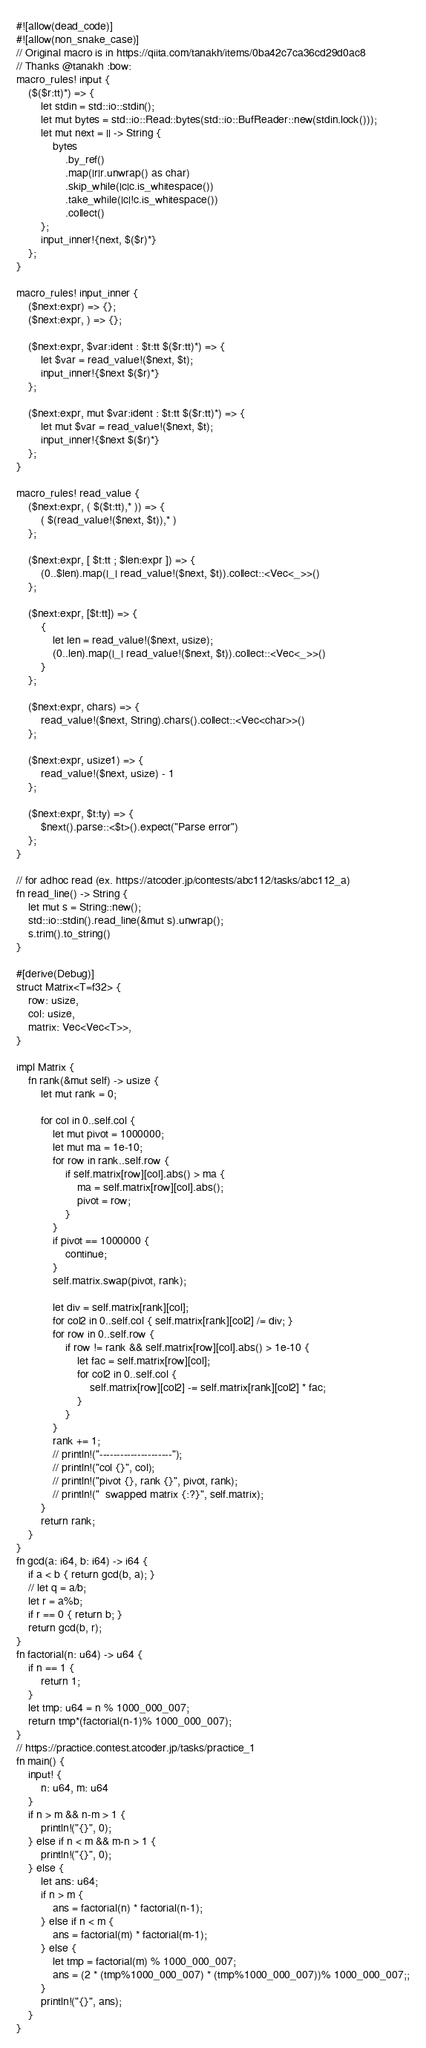<code> <loc_0><loc_0><loc_500><loc_500><_Rust_>#![allow(dead_code)]
#![allow(non_snake_case)]
// Original macro is in https://qiita.com/tanakh/items/0ba42c7ca36cd29d0ac8
// Thanks @tanakh :bow:
macro_rules! input {
    ($($r:tt)*) => {
        let stdin = std::io::stdin();
        let mut bytes = std::io::Read::bytes(std::io::BufReader::new(stdin.lock()));
        let mut next = || -> String {
            bytes
                .by_ref()
                .map(|r|r.unwrap() as char)
                .skip_while(|c|c.is_whitespace())
                .take_while(|c|!c.is_whitespace())
                .collect()
        };
        input_inner!{next, $($r)*}
    };
}
 
macro_rules! input_inner {
    ($next:expr) => {};
    ($next:expr, ) => {};
 
    ($next:expr, $var:ident : $t:tt $($r:tt)*) => {
        let $var = read_value!($next, $t);
        input_inner!{$next $($r)*}
    };
    
    ($next:expr, mut $var:ident : $t:tt $($r:tt)*) => {
        let mut $var = read_value!($next, $t);
        input_inner!{$next $($r)*}
    };
}
 
macro_rules! read_value {
    ($next:expr, ( $($t:tt),* )) => {
        ( $(read_value!($next, $t)),* )
    };
 
    ($next:expr, [ $t:tt ; $len:expr ]) => {
        (0..$len).map(|_| read_value!($next, $t)).collect::<Vec<_>>()
    };

    ($next:expr, [$t:tt]) => {
        {
            let len = read_value!($next, usize);
            (0..len).map(|_| read_value!($next, $t)).collect::<Vec<_>>()
        }
    };
 
    ($next:expr, chars) => {
        read_value!($next, String).chars().collect::<Vec<char>>()
    };
 
    ($next:expr, usize1) => {
        read_value!($next, usize) - 1
    };
 
    ($next:expr, $t:ty) => {
        $next().parse::<$t>().expect("Parse error")
    };
}

// for adhoc read (ex. https://atcoder.jp/contests/abc112/tasks/abc112_a)
fn read_line() -> String {
    let mut s = String::new();
    std::io::stdin().read_line(&mut s).unwrap();
    s.trim().to_string()
}

#[derive(Debug)]
struct Matrix<T=f32> {
    row: usize,
    col: usize,
    matrix: Vec<Vec<T>>,
}

impl Matrix {
    fn rank(&mut self) -> usize {
        let mut rank = 0;

        for col in 0..self.col {
            let mut pivot = 1000000;
            let mut ma = 1e-10;
            for row in rank..self.row {
                if self.matrix[row][col].abs() > ma {
                    ma = self.matrix[row][col].abs();
                    pivot = row;
                }
            }
            if pivot == 1000000 {
                continue;
            }
            self.matrix.swap(pivot, rank);

            let div = self.matrix[rank][col];
            for col2 in 0..self.col { self.matrix[rank][col2] /= div; }
            for row in 0..self.row {
                if row != rank && self.matrix[row][col].abs() > 1e-10 {
                    let fac = self.matrix[row][col];
                    for col2 in 0..self.col {
                        self.matrix[row][col2] -= self.matrix[rank][col2] * fac;
                    }
                }
            }
            rank += 1;
            // println!("---------------------");
            // println!("col {}", col);
            // println!("pivot {}, rank {}", pivot, rank);
            // println!("  swapped matrix {:?}", self.matrix);
        }
        return rank;
    }
}
fn gcd(a: i64, b: i64) -> i64 {
    if a < b { return gcd(b, a); }
    // let q = a/b;
    let r = a%b;
    if r == 0 { return b; }
    return gcd(b, r);
}
fn factorial(n: u64) -> u64 {
    if n == 1 {
        return 1;
    }
    let tmp: u64 = n % 1000_000_007;
    return tmp*(factorial(n-1)% 1000_000_007);
}
// https://practice.contest.atcoder.jp/tasks/practice_1
fn main() {
    input! {
        n: u64, m: u64
    }
    if n > m && n-m > 1 {
        println!("{}", 0);
    } else if n < m && m-n > 1 {
        println!("{}", 0);
    } else {
        let ans: u64;
        if n > m {
            ans = factorial(n) * factorial(n-1);
        } else if n < m {
            ans = factorial(m) * factorial(m-1);
        } else {
            let tmp = factorial(m) % 1000_000_007;
            ans = (2 * (tmp%1000_000_007) * (tmp%1000_000_007))% 1000_000_007;;
        }
        println!("{}", ans);
    }
}</code> 